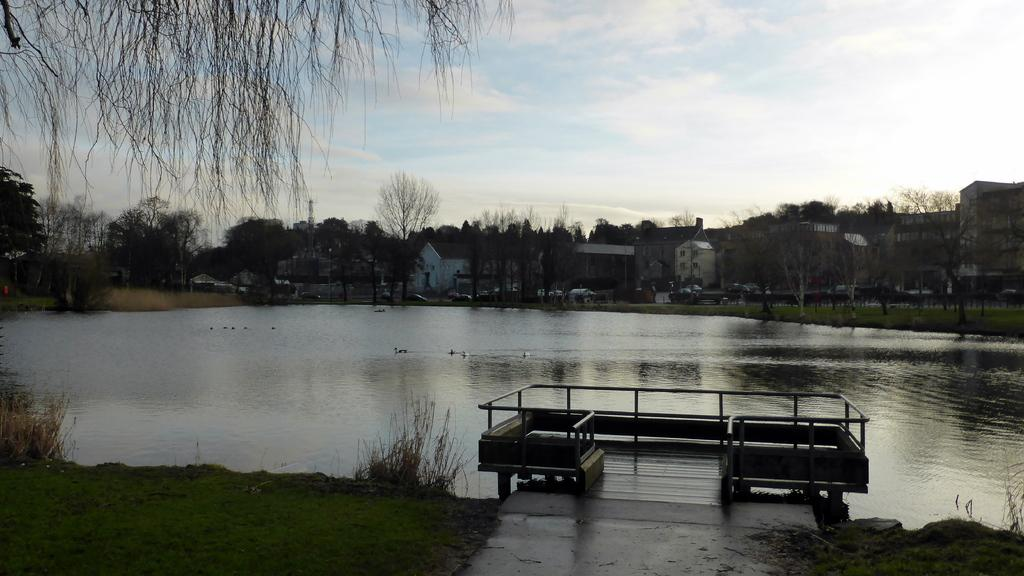What type of structures can be seen in the image? There are buildings in the image. What other natural elements are present in the image? There are trees and water visible in the image. What part of the natural environment is visible in the image? The sky is visible in the image. What type of milk is being served in the image? There is no milk present in the image; it features buildings, trees, water, and the sky. 